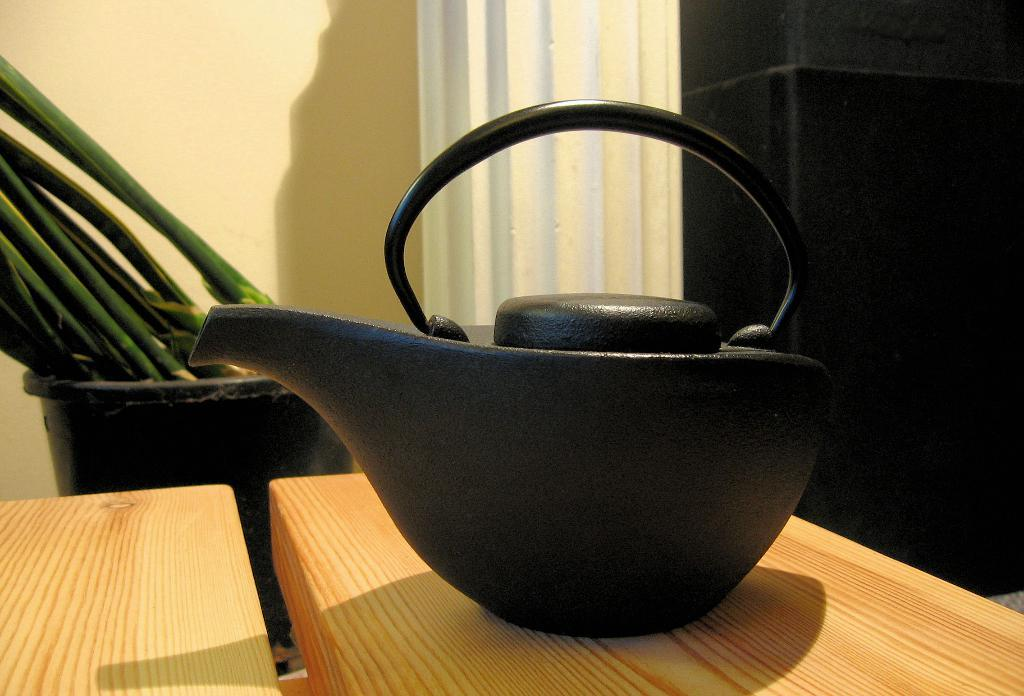What is the color of the object on the wooden table? The object on the wooden table is black. What type of plant is visible in the image? There is there any vegetation? What type of surface is the object on? The object is on a wooden table. What can be seen in the background of the image? There is a wall visible in the image. What type of grain is being harvested in the image? There is no grain or harvesting activity present in the image. Can you see any insects in the image? There are no insects visible in the image. 